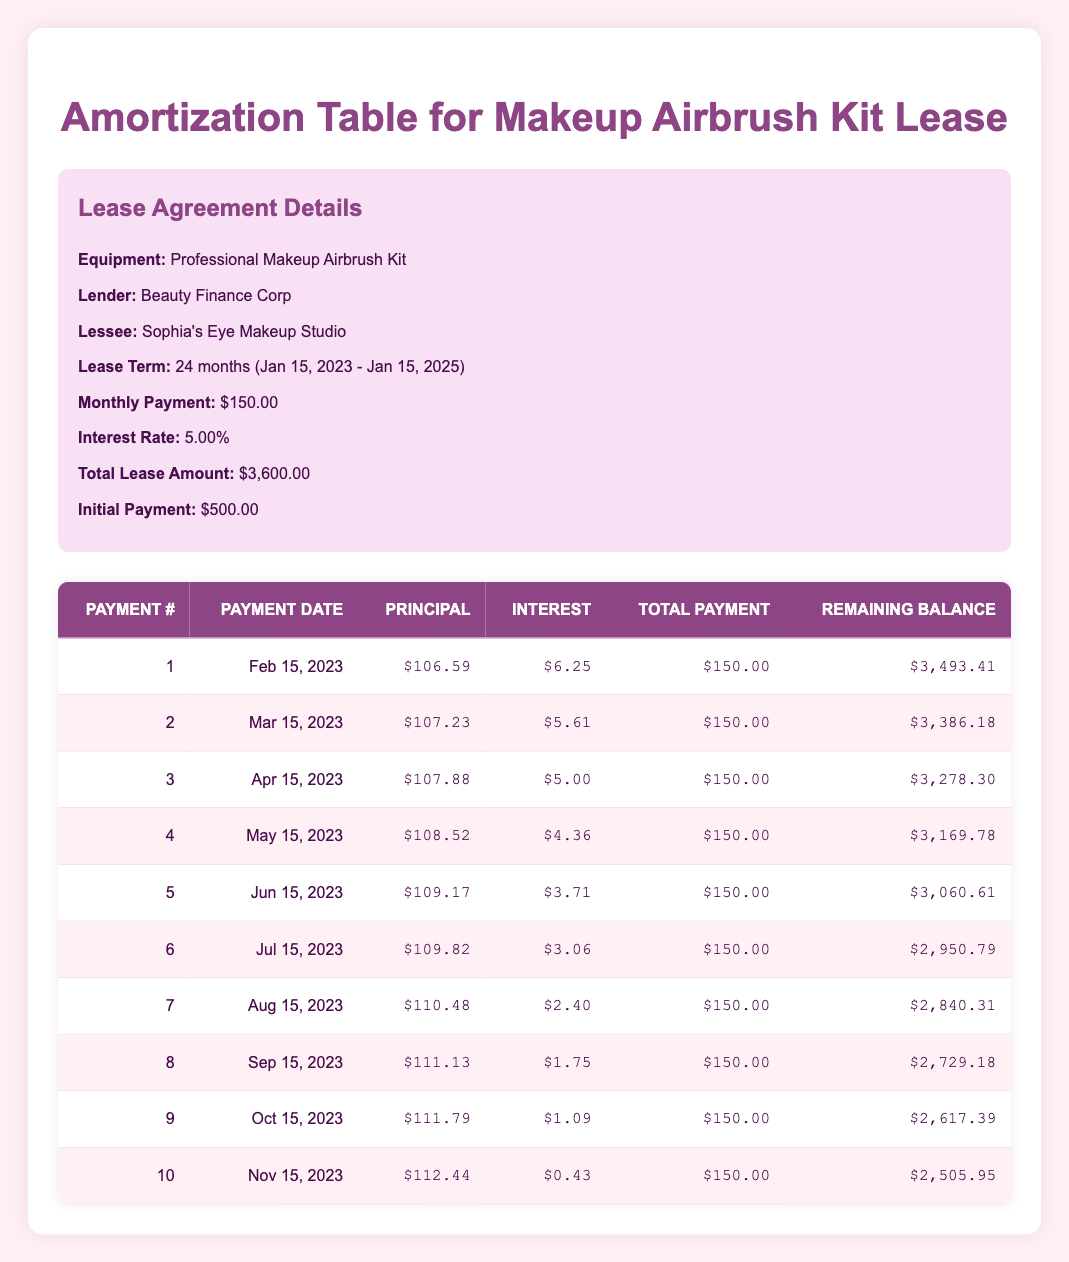What is the monthly payment for the lease? The table specifies that the monthly payment for the lease is $150.00.
Answer: 150.00 What is the remaining balance after the third payment? After the third payment, the remaining balance shown in the table is $3,278.30.
Answer: 3,278.30 How much was paid towards principal in the first two payments combined? The principal payments for the first two payments are $106.59 and $107.23, respectively. Adding these together gives $106.59 + $107.23 = $213.82.
Answer: 213.82 Is the total payment the same for all payments in the schedule? Yes, the total payment remains constant at $150.00 for each payment listed in the schedule.
Answer: Yes What is the difference in remaining balance between the first and tenth payments? The remaining balance after the first payment is $3,493.41, and after the tenth payment, it is $2,505.95. The difference is calculated as $3,493.41 - $2,505.95 = $987.46.
Answer: 987.46 What is the average principal payment for the first five payments? The principal payments for the first five payments are $106.59, $107.23, $107.88, $108.52, and $109.17. The sum is $106.59 + $107.23 + $107.88 + $108.52 + $109.17 = $539.39. The average is $539.39 / 5 = $107.88.
Answer: 107.88 How much interest is paid in the fourth payment? The interest portion of the fourth payment, as shown in the table, is $4.36.
Answer: 4.36 How many months are left in the lease after the sixth payment? The lease term is 24 months, and after 6 payments, 18 months are left. This can be calculated as 24 - 6 = 18.
Answer: 18 What is the total interest paid by the end of the sixth payment? To find the total interest paid by the end of the sixth payment, we sum the interest payments of the first six payments: $6.25 + $5.61 + $5.00 + $4.36 + $3.71 + $3.06 = $27.99.
Answer: 27.99 